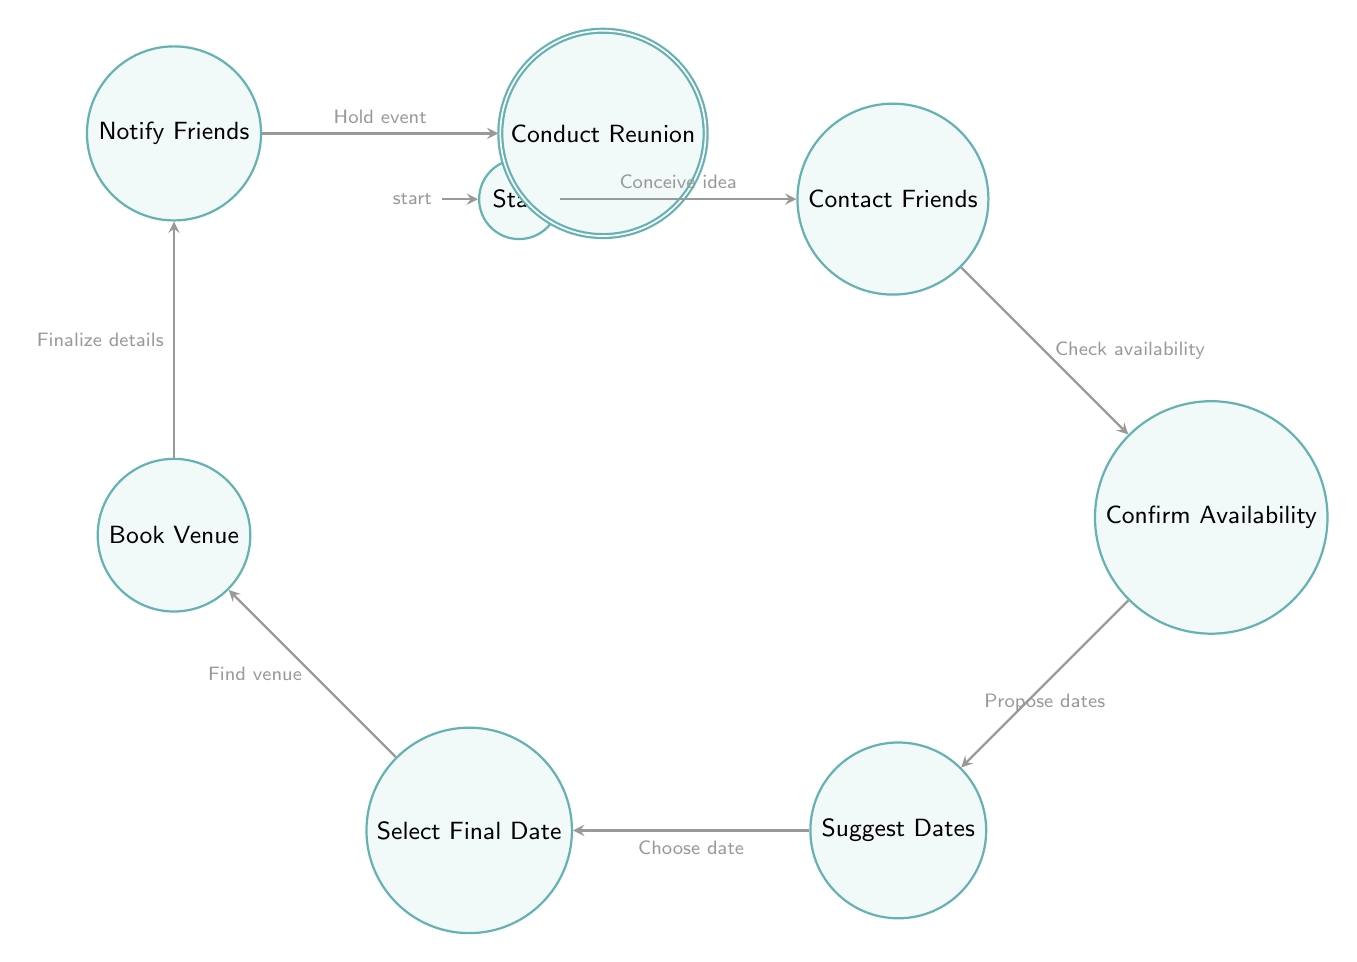What is the initial state in the diagram? The initial state in the diagram is represented by the first state node, labeled "Start," which indicates the beginning of the process for scheduling a reunion event.
Answer: Start How many states are there in the diagram? By counting the nodes in the diagram, there are a total of 8 states, which include Start, Contact Friends, Confirm Availability, Suggest Dates, Select Final Date, Book Venue, Notify Friends, and Conduct Reunion.
Answer: 8 What is the final state of the diagram? The final state is indicated by the accepting node, which is labeled "Conduct Reunion," representing the completion of the process.
Answer: Conduct Reunion What is the transition from "Contact Friends" to "Confirm Availability" called? This transition is labeled "Check availability," indicating the action taken after reaching out to friends to assess their availability for the reunion.
Answer: Check availability Which state follows "Notify Friends"? According to the transition flow, the state that follows "Notify Friends" is "Conduct Reunion," signifying the actual event taking place after notifications have been sent.
Answer: Conduct Reunion What must be done before booking a venue? Before booking a venue, the final date must be selected, as indicated by the transition "Choose date," which is essential to determine when the venue should be reserved.
Answer: Select Final Date What transition occurs after suggesting dates? After suggesting dates, the next transition is labeled "Choose date," indicating that the group will select one of the proposed options for the reunion date.
Answer: Choose date How do you proceed after confirming availability? Once availability is confirmed, you move to the state labeled "Suggest Dates," where possible dates for the reunion are proposed to the friends based on their responses.
Answer: Suggest Dates What is the action taken after booking the venue? After booking the venue, the next action is to transition to the state labeled "Notify Friends," where the finalized details of the reunion are communicated to all friends involved.
Answer: Notify Friends 